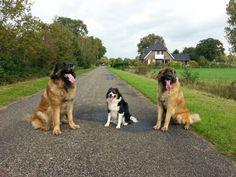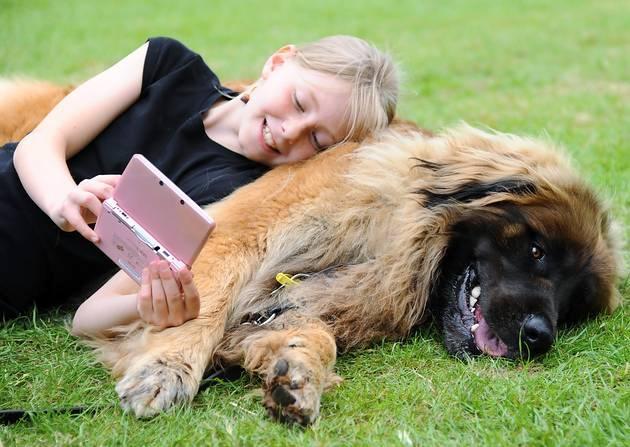The first image is the image on the left, the second image is the image on the right. Given the left and right images, does the statement "There are three or more dogs." hold true? Answer yes or no. Yes. The first image is the image on the left, the second image is the image on the right. Analyze the images presented: Is the assertion "An image includes a furry dog lying on green foliage." valid? Answer yes or no. Yes. 